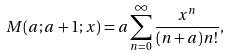Convert formula to latex. <formula><loc_0><loc_0><loc_500><loc_500>M ( a ; a + 1 ; x ) = a \sum _ { n = 0 } ^ { \infty } \frac { x ^ { n } } { ( n + a ) n ! } ,</formula> 